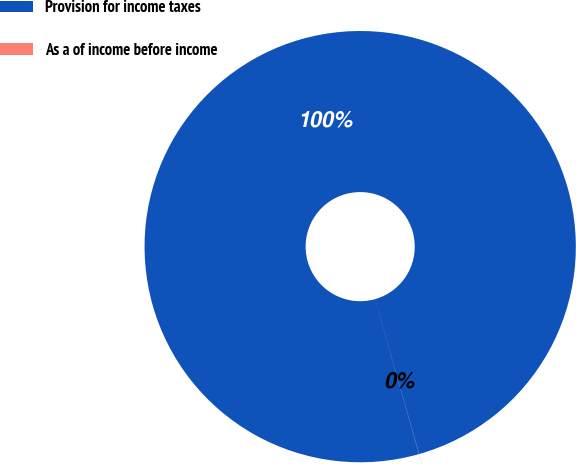Convert chart to OTSL. <chart><loc_0><loc_0><loc_500><loc_500><pie_chart><fcel>Provision for income taxes<fcel>As a of income before income<nl><fcel>99.99%<fcel>0.01%<nl></chart> 